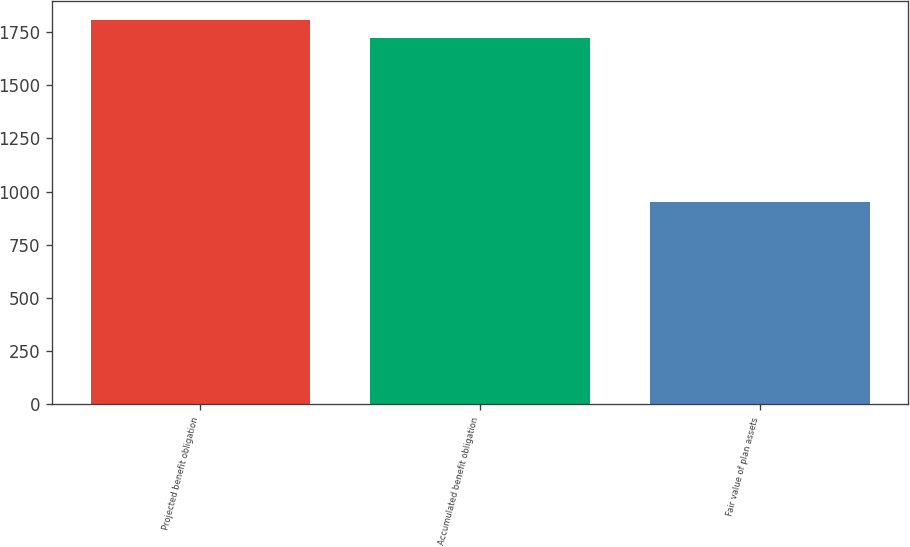Convert chart. <chart><loc_0><loc_0><loc_500><loc_500><bar_chart><fcel>Projected benefit obligation<fcel>Accumulated benefit obligation<fcel>Fair value of plan assets<nl><fcel>1805.1<fcel>1720<fcel>950<nl></chart> 